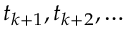<formula> <loc_0><loc_0><loc_500><loc_500>t _ { k + 1 } , t _ { k + 2 } , \dots</formula> 